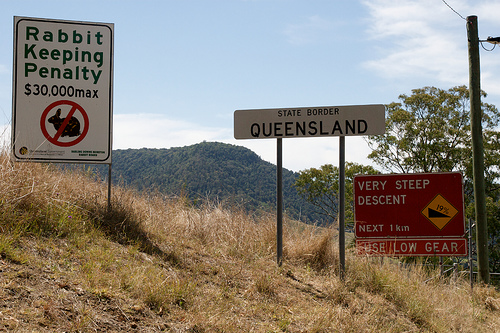<image>
Can you confirm if the sign is on the hill? Yes. Looking at the image, I can see the sign is positioned on top of the hill, with the hill providing support. 